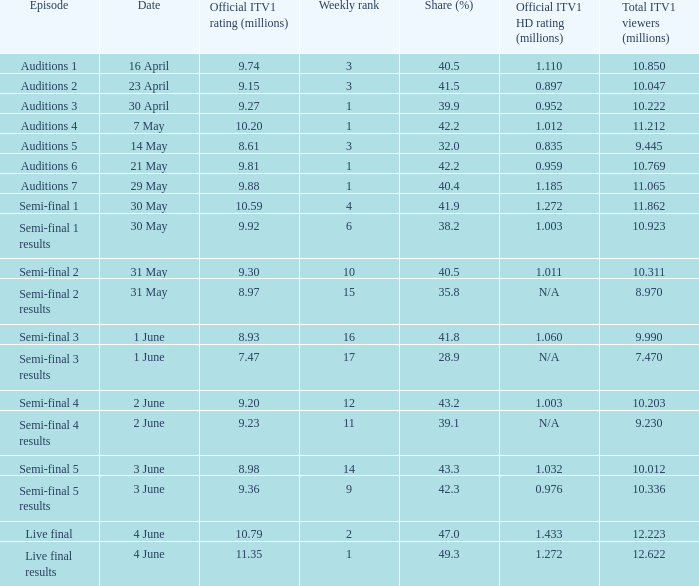What was the total ITV1 viewers in millions for the episode with a share (%) of 28.9?  7.47. 